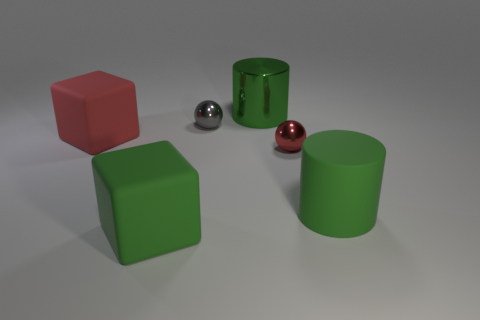Add 3 cyan matte spheres. How many objects exist? 9 Subtract all green things. Subtract all large matte blocks. How many objects are left? 1 Add 6 small red metallic things. How many small red metallic things are left? 7 Add 5 large red cubes. How many large red cubes exist? 6 Subtract 0 blue cylinders. How many objects are left? 6 Subtract all blocks. How many objects are left? 4 